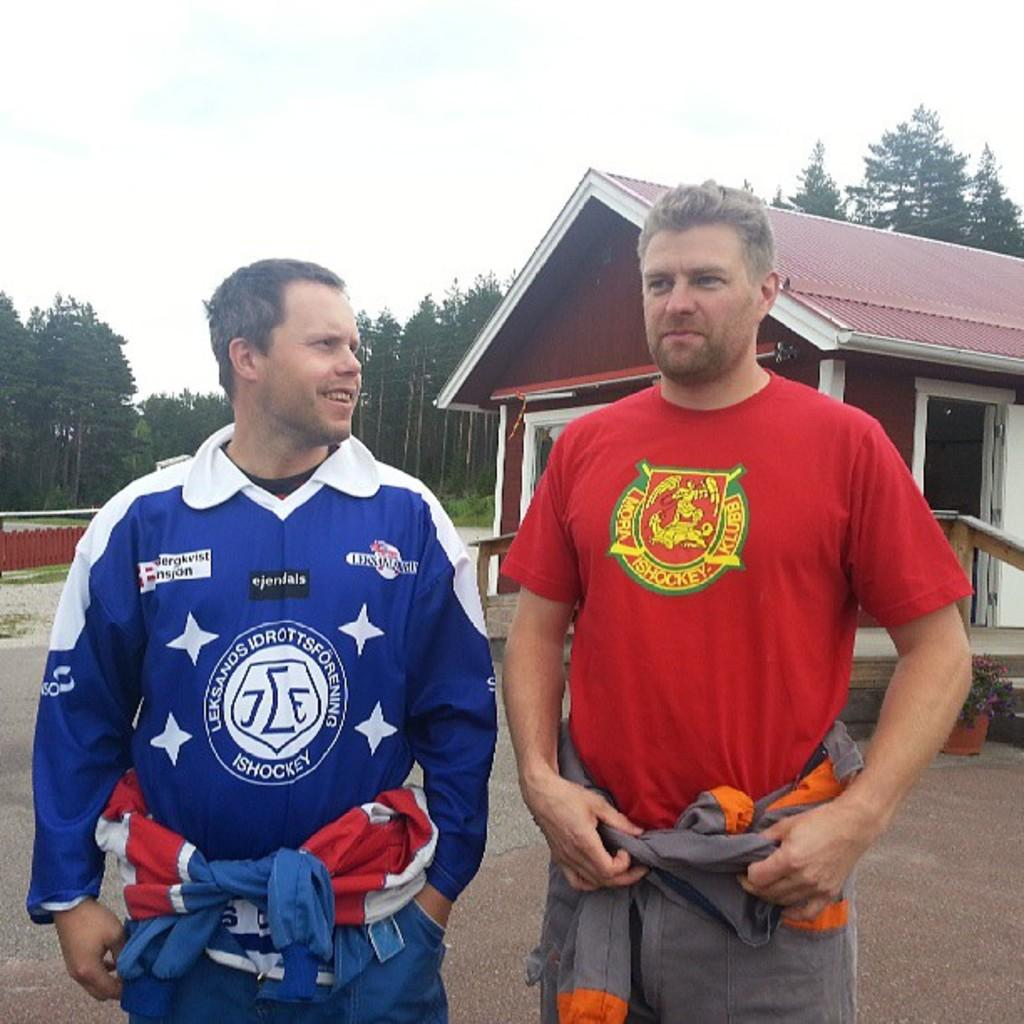Provide a one-sentence caption for the provided image. Two men wear different shirts that both have the word ISHOCKEY on them. 